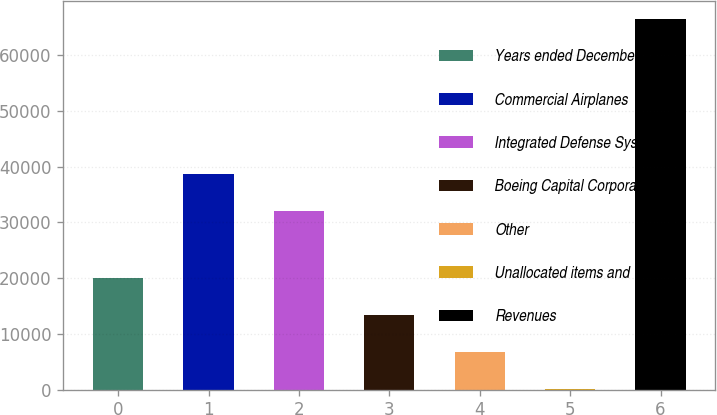<chart> <loc_0><loc_0><loc_500><loc_500><bar_chart><fcel>Years ended December 31<fcel>Commercial Airplanes<fcel>Integrated Defense Systems<fcel>Boeing Capital Corporation<fcel>Other<fcel>Unallocated items and<fcel>Revenues<nl><fcel>20037.9<fcel>38673.3<fcel>32052<fcel>13416.6<fcel>6795.3<fcel>174<fcel>66387<nl></chart> 